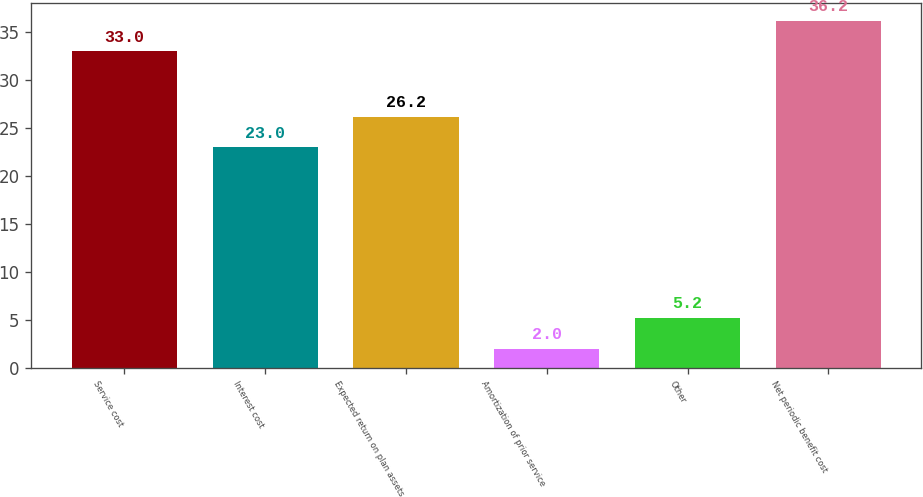Convert chart to OTSL. <chart><loc_0><loc_0><loc_500><loc_500><bar_chart><fcel>Service cost<fcel>Interest cost<fcel>Expected return on plan assets<fcel>Amortization of prior service<fcel>Other<fcel>Net periodic benefit cost<nl><fcel>33<fcel>23<fcel>26.2<fcel>2<fcel>5.2<fcel>36.2<nl></chart> 